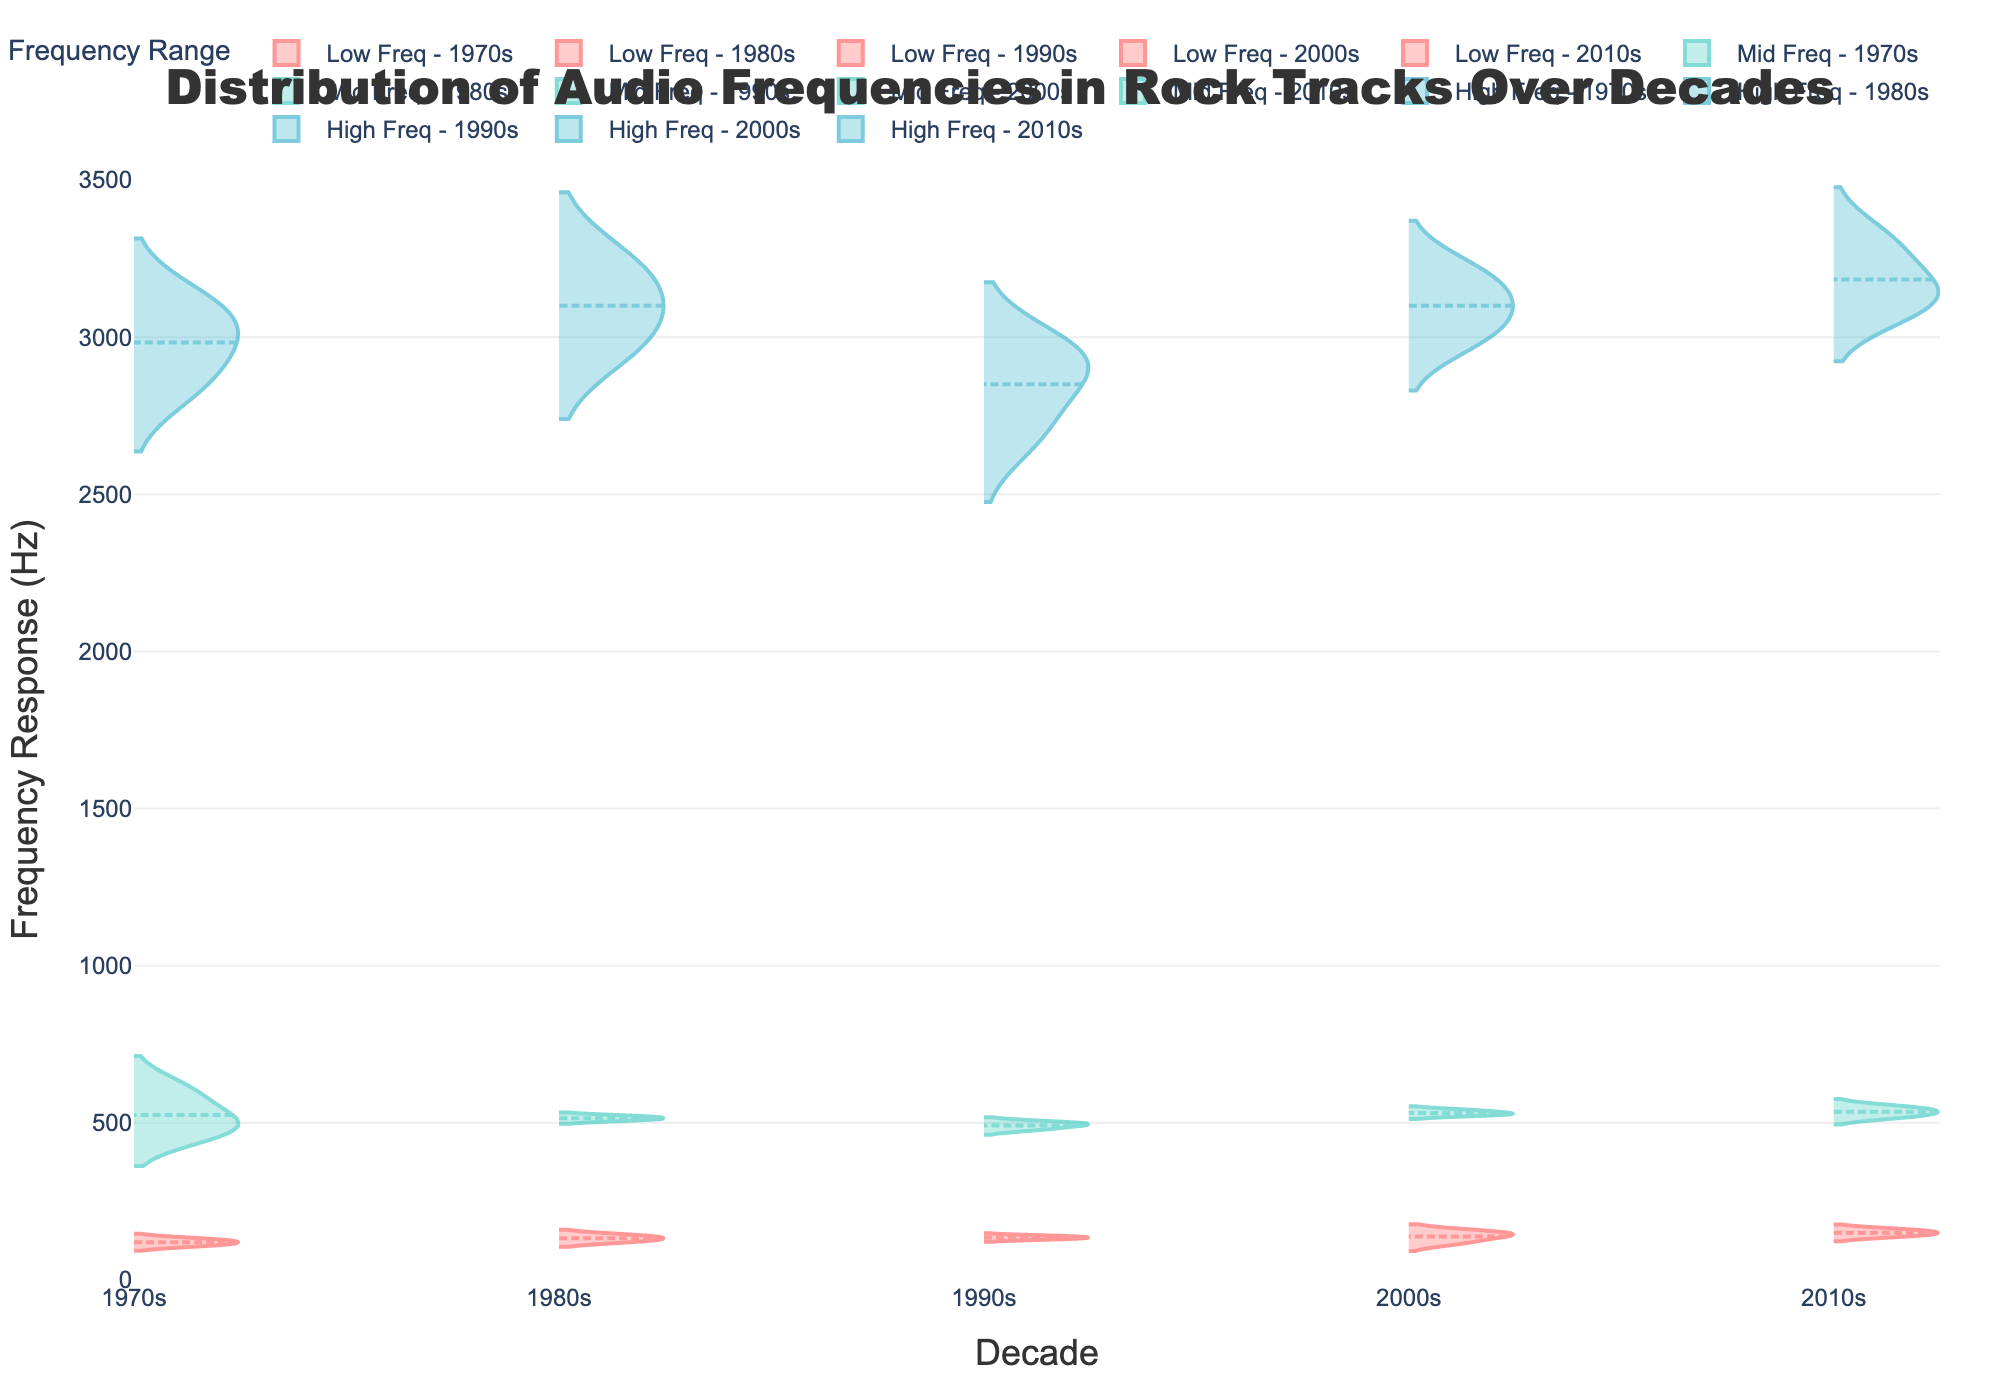What's the title of the plot? The title is located at the top of the figure, centered, and can be read directly. It states "Distribution of Audio Frequencies in Rock Tracks Over Decades".
Answer: Distribution of Audio Frequencies in Rock Tracks Over Decades What are the x- and y-axes titles? The x-axis title can be found at the bottom of the x-axis and reads "Decade". The y-axis title is along the y-axis, reading "Frequency Response (Hz)".
Answer: Decade and Frequency Response (Hz) How many different frequency ranges are visualized? By examining the legend, you can see there are three different frequency types: Low, Mid, and High Frequency Responses.
Answer: Three Which decade has the lowest average low frequency response? By observing the violin plots, the 1970s show a lower overall average value in the Low Frequency Response compared to other decades.
Answer: 1970s Which decade features the highest high frequency response spread? The widest spread in the high frequency response, i.e., the violin plot with the maximum vertical extent, is observed in the 2010s.
Answer: 2010s What is the general trend for mid frequency responses over the decades? The mid frequency responses show a gradual increase in values as the decades progress from the 1970s to the 2010s, indicating an upward trend.
Answer: Increasing Which frequency range varies the least over the decades? The violin plots for the Mid Frequency Response have the most uniform appearance in terms of spread and central tendencies across the decades, indicating less variation than the Low and High Frequencies.
Answer: Mid Frequency Response In which decade are the high frequency responses generally above 3000 Hz? By examining the violin plots, the high frequency responses in the 2000s and 2010s show many values above 3000 Hz.
Answer: 2000s and 2010s Compare the low frequency responses of the 1970s and 1980s: which is generally higher? The violin plots for the Low Frequency Response show that the 1980s have generally higher values compared to the 1970s.
Answer: 1980s How does the distribution of mid frequency responses change from the 1970s to the 2010s? By analyzing the violin plots for the mid frequency responses, it is evident that there is a noticeable shift upwards in values, suggesting a trend toward higher mid frequencies in the more recent decades.
Answer: Upward shift 